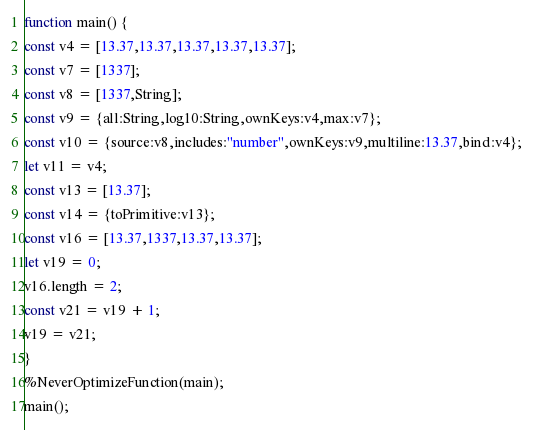Convert code to text. <code><loc_0><loc_0><loc_500><loc_500><_JavaScript_>function main() {
const v4 = [13.37,13.37,13.37,13.37,13.37];
const v7 = [1337];
const v8 = [1337,String];
const v9 = {all:String,log10:String,ownKeys:v4,max:v7};
const v10 = {source:v8,includes:"number",ownKeys:v9,multiline:13.37,bind:v4};
let v11 = v4;
const v13 = [13.37];
const v14 = {toPrimitive:v13};
const v16 = [13.37,1337,13.37,13.37];
let v19 = 0;
v16.length = 2;
const v21 = v19 + 1;
v19 = v21;
}
%NeverOptimizeFunction(main);
main();
</code> 